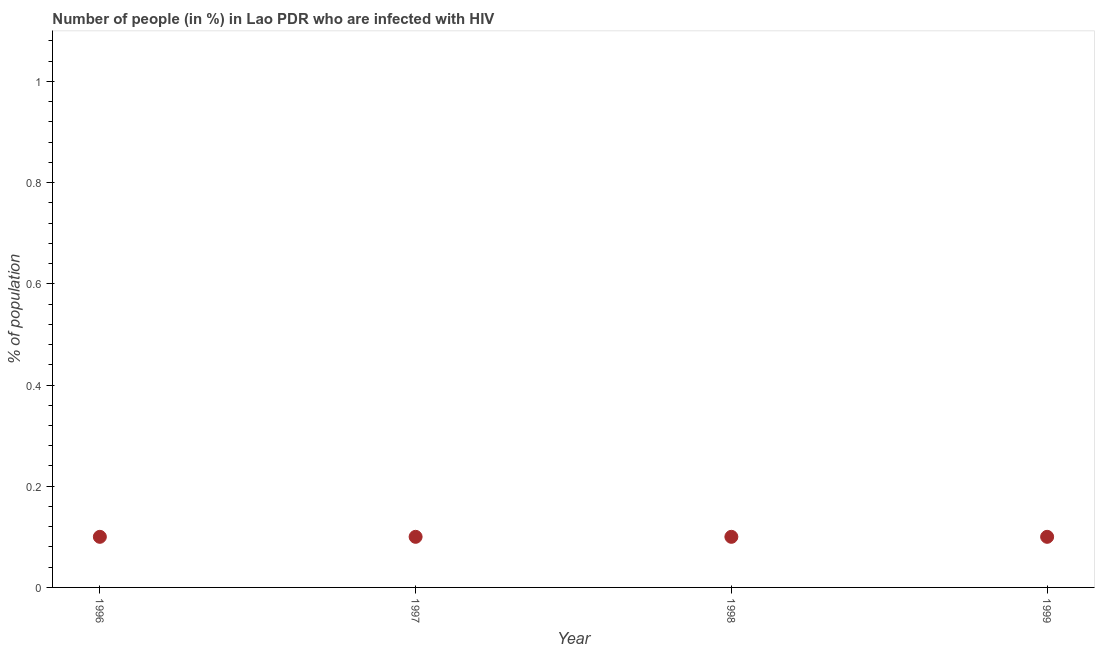What is the number of people infected with hiv in 1996?
Keep it short and to the point. 0.1. In which year was the number of people infected with hiv maximum?
Your answer should be very brief. 1996. What is the average number of people infected with hiv per year?
Offer a terse response. 0.1. What is the median number of people infected with hiv?
Keep it short and to the point. 0.1. In how many years, is the number of people infected with hiv greater than 0.28 %?
Give a very brief answer. 0. Do a majority of the years between 1998 and 1997 (inclusive) have number of people infected with hiv greater than 0.04 %?
Ensure brevity in your answer.  No. Is the number of people infected with hiv in 1996 less than that in 1999?
Your answer should be compact. No. What is the difference between the highest and the second highest number of people infected with hiv?
Give a very brief answer. 0. In how many years, is the number of people infected with hiv greater than the average number of people infected with hiv taken over all years?
Offer a very short reply. 0. Does the number of people infected with hiv monotonically increase over the years?
Keep it short and to the point. No. How many dotlines are there?
Offer a terse response. 1. How many years are there in the graph?
Make the answer very short. 4. What is the difference between two consecutive major ticks on the Y-axis?
Provide a succinct answer. 0.2. Does the graph contain any zero values?
Ensure brevity in your answer.  No. Does the graph contain grids?
Your answer should be compact. No. What is the title of the graph?
Keep it short and to the point. Number of people (in %) in Lao PDR who are infected with HIV. What is the label or title of the Y-axis?
Offer a very short reply. % of population. What is the % of population in 1999?
Give a very brief answer. 0.1. What is the difference between the % of population in 1996 and 1997?
Offer a terse response. 0. What is the difference between the % of population in 1996 and 1999?
Make the answer very short. 0. What is the difference between the % of population in 1997 and 1998?
Provide a succinct answer. 0. What is the difference between the % of population in 1997 and 1999?
Your answer should be very brief. 0. What is the difference between the % of population in 1998 and 1999?
Your response must be concise. 0. What is the ratio of the % of population in 1996 to that in 1998?
Provide a short and direct response. 1. What is the ratio of the % of population in 1997 to that in 1998?
Keep it short and to the point. 1. 